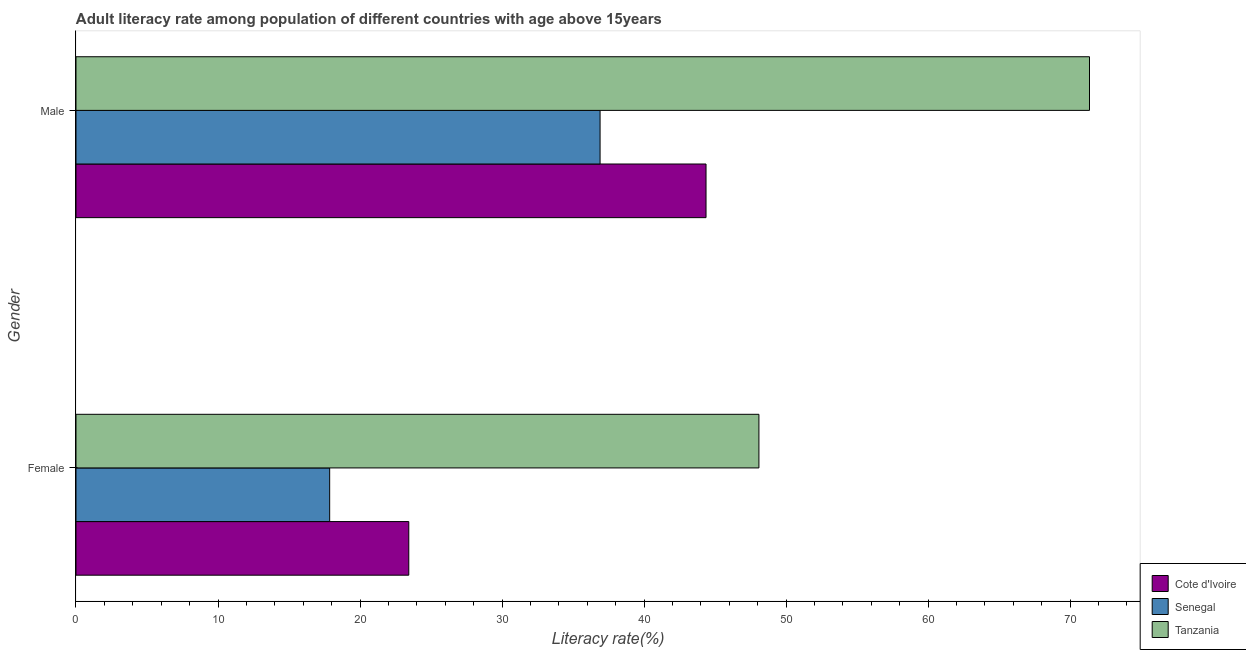How many bars are there on the 2nd tick from the top?
Provide a succinct answer. 3. What is the label of the 2nd group of bars from the top?
Offer a very short reply. Female. What is the male adult literacy rate in Senegal?
Offer a terse response. 36.9. Across all countries, what is the maximum female adult literacy rate?
Ensure brevity in your answer.  48.09. Across all countries, what is the minimum male adult literacy rate?
Provide a succinct answer. 36.9. In which country was the male adult literacy rate maximum?
Your response must be concise. Tanzania. In which country was the female adult literacy rate minimum?
Provide a short and direct response. Senegal. What is the total male adult literacy rate in the graph?
Provide a short and direct response. 152.63. What is the difference between the male adult literacy rate in Tanzania and that in Cote d'Ivoire?
Offer a very short reply. 27. What is the difference between the male adult literacy rate in Senegal and the female adult literacy rate in Cote d'Ivoire?
Your answer should be compact. 13.47. What is the average male adult literacy rate per country?
Your answer should be very brief. 50.88. What is the difference between the female adult literacy rate and male adult literacy rate in Senegal?
Keep it short and to the point. -19.04. In how many countries, is the female adult literacy rate greater than 48 %?
Ensure brevity in your answer.  1. What is the ratio of the male adult literacy rate in Tanzania to that in Senegal?
Offer a very short reply. 1.93. In how many countries, is the male adult literacy rate greater than the average male adult literacy rate taken over all countries?
Your answer should be very brief. 1. What does the 3rd bar from the top in Female represents?
Offer a very short reply. Cote d'Ivoire. What does the 2nd bar from the bottom in Female represents?
Offer a terse response. Senegal. Are all the bars in the graph horizontal?
Offer a terse response. Yes. How many countries are there in the graph?
Your response must be concise. 3. What is the difference between two consecutive major ticks on the X-axis?
Ensure brevity in your answer.  10. Does the graph contain any zero values?
Make the answer very short. No. Where does the legend appear in the graph?
Provide a short and direct response. Bottom right. How many legend labels are there?
Keep it short and to the point. 3. What is the title of the graph?
Give a very brief answer. Adult literacy rate among population of different countries with age above 15years. What is the label or title of the X-axis?
Ensure brevity in your answer.  Literacy rate(%). What is the Literacy rate(%) in Cote d'Ivoire in Female?
Keep it short and to the point. 23.43. What is the Literacy rate(%) in Senegal in Female?
Ensure brevity in your answer.  17.86. What is the Literacy rate(%) of Tanzania in Female?
Provide a short and direct response. 48.09. What is the Literacy rate(%) in Cote d'Ivoire in Male?
Provide a short and direct response. 44.36. What is the Literacy rate(%) in Senegal in Male?
Ensure brevity in your answer.  36.9. What is the Literacy rate(%) in Tanzania in Male?
Ensure brevity in your answer.  71.37. Across all Gender, what is the maximum Literacy rate(%) in Cote d'Ivoire?
Offer a terse response. 44.36. Across all Gender, what is the maximum Literacy rate(%) in Senegal?
Offer a terse response. 36.9. Across all Gender, what is the maximum Literacy rate(%) in Tanzania?
Provide a succinct answer. 71.37. Across all Gender, what is the minimum Literacy rate(%) in Cote d'Ivoire?
Provide a short and direct response. 23.43. Across all Gender, what is the minimum Literacy rate(%) in Senegal?
Give a very brief answer. 17.86. Across all Gender, what is the minimum Literacy rate(%) of Tanzania?
Make the answer very short. 48.09. What is the total Literacy rate(%) in Cote d'Ivoire in the graph?
Offer a very short reply. 67.8. What is the total Literacy rate(%) of Senegal in the graph?
Your answer should be compact. 54.77. What is the total Literacy rate(%) of Tanzania in the graph?
Keep it short and to the point. 119.45. What is the difference between the Literacy rate(%) of Cote d'Ivoire in Female and that in Male?
Your response must be concise. -20.93. What is the difference between the Literacy rate(%) in Senegal in Female and that in Male?
Make the answer very short. -19.04. What is the difference between the Literacy rate(%) in Tanzania in Female and that in Male?
Make the answer very short. -23.28. What is the difference between the Literacy rate(%) in Cote d'Ivoire in Female and the Literacy rate(%) in Senegal in Male?
Your answer should be very brief. -13.47. What is the difference between the Literacy rate(%) in Cote d'Ivoire in Female and the Literacy rate(%) in Tanzania in Male?
Your response must be concise. -47.93. What is the difference between the Literacy rate(%) of Senegal in Female and the Literacy rate(%) of Tanzania in Male?
Offer a terse response. -53.5. What is the average Literacy rate(%) in Cote d'Ivoire per Gender?
Your answer should be very brief. 33.9. What is the average Literacy rate(%) in Senegal per Gender?
Offer a terse response. 27.38. What is the average Literacy rate(%) of Tanzania per Gender?
Provide a succinct answer. 59.73. What is the difference between the Literacy rate(%) in Cote d'Ivoire and Literacy rate(%) in Senegal in Female?
Your answer should be very brief. 5.57. What is the difference between the Literacy rate(%) in Cote d'Ivoire and Literacy rate(%) in Tanzania in Female?
Give a very brief answer. -24.65. What is the difference between the Literacy rate(%) of Senegal and Literacy rate(%) of Tanzania in Female?
Your response must be concise. -30.22. What is the difference between the Literacy rate(%) of Cote d'Ivoire and Literacy rate(%) of Senegal in Male?
Ensure brevity in your answer.  7.46. What is the difference between the Literacy rate(%) of Cote d'Ivoire and Literacy rate(%) of Tanzania in Male?
Your answer should be compact. -27. What is the difference between the Literacy rate(%) in Senegal and Literacy rate(%) in Tanzania in Male?
Keep it short and to the point. -34.46. What is the ratio of the Literacy rate(%) in Cote d'Ivoire in Female to that in Male?
Provide a short and direct response. 0.53. What is the ratio of the Literacy rate(%) in Senegal in Female to that in Male?
Keep it short and to the point. 0.48. What is the ratio of the Literacy rate(%) in Tanzania in Female to that in Male?
Offer a very short reply. 0.67. What is the difference between the highest and the second highest Literacy rate(%) in Cote d'Ivoire?
Provide a succinct answer. 20.93. What is the difference between the highest and the second highest Literacy rate(%) of Senegal?
Give a very brief answer. 19.04. What is the difference between the highest and the second highest Literacy rate(%) in Tanzania?
Ensure brevity in your answer.  23.28. What is the difference between the highest and the lowest Literacy rate(%) in Cote d'Ivoire?
Your response must be concise. 20.93. What is the difference between the highest and the lowest Literacy rate(%) in Senegal?
Ensure brevity in your answer.  19.04. What is the difference between the highest and the lowest Literacy rate(%) of Tanzania?
Make the answer very short. 23.28. 